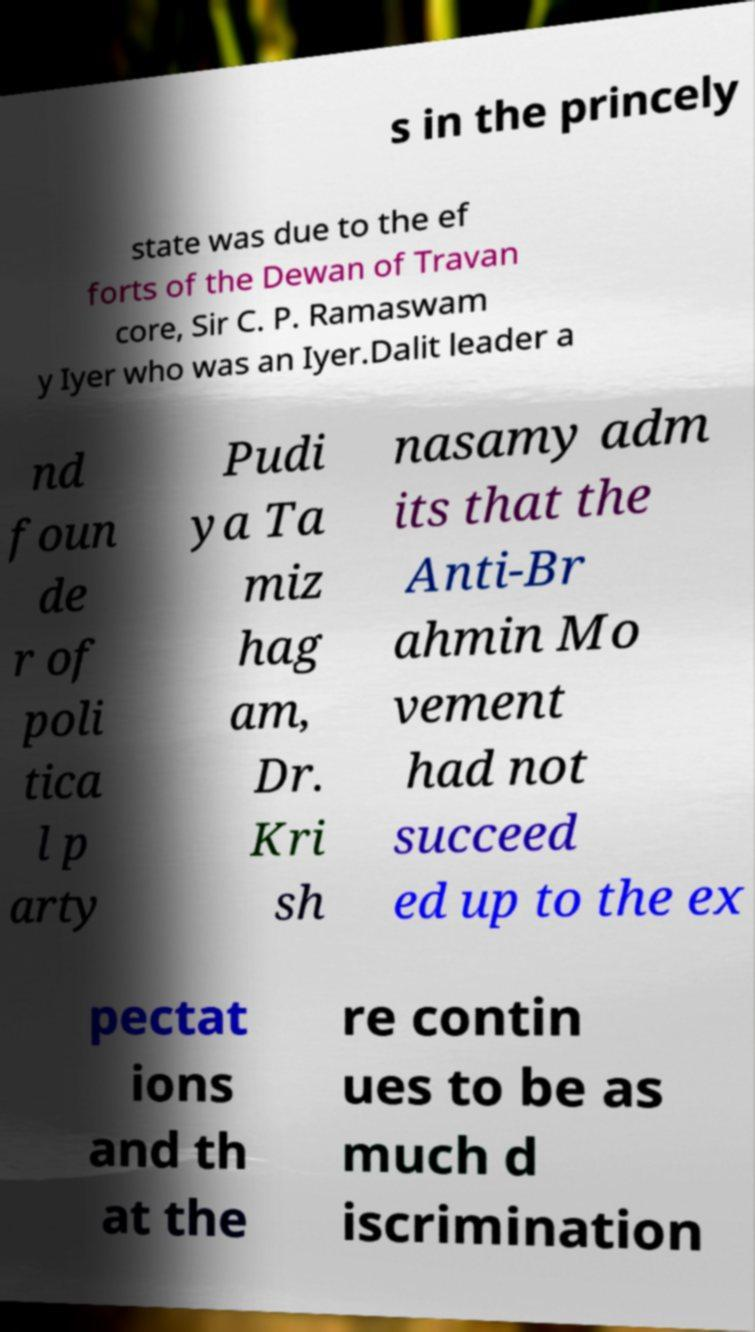I need the written content from this picture converted into text. Can you do that? s in the princely state was due to the ef forts of the Dewan of Travan core, Sir C. P. Ramaswam y Iyer who was an Iyer.Dalit leader a nd foun de r of poli tica l p arty Pudi ya Ta miz hag am, Dr. Kri sh nasamy adm its that the Anti-Br ahmin Mo vement had not succeed ed up to the ex pectat ions and th at the re contin ues to be as much d iscrimination 